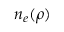<formula> <loc_0><loc_0><loc_500><loc_500>n _ { e } ( \rho )</formula> 